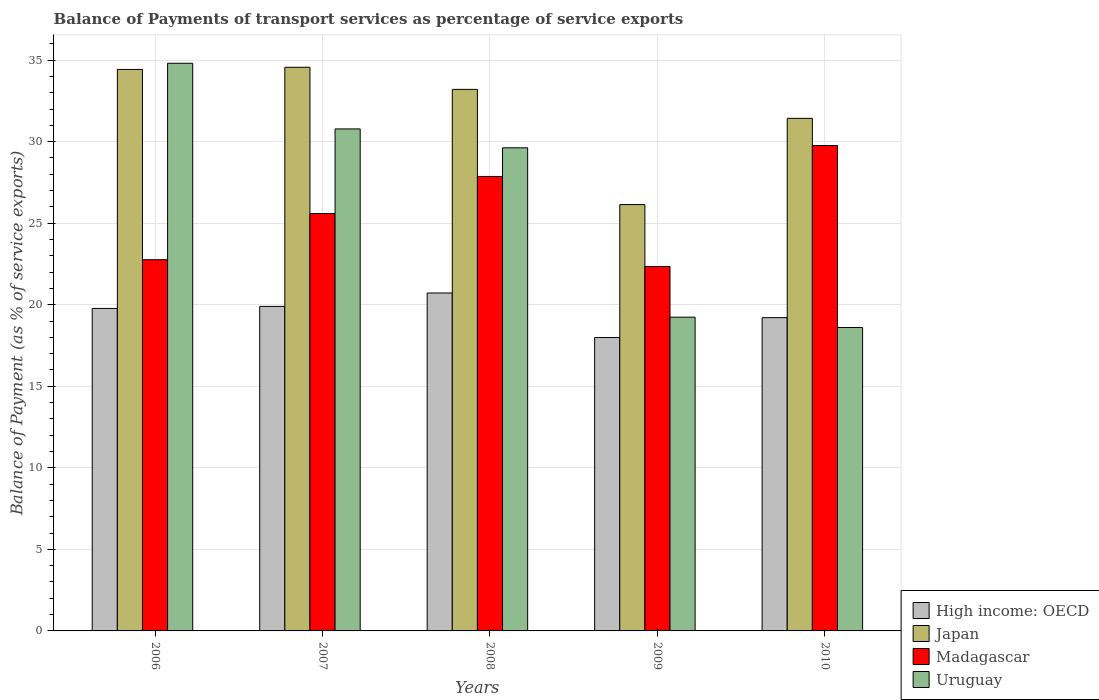How many groups of bars are there?
Provide a succinct answer. 5. Are the number of bars per tick equal to the number of legend labels?
Your response must be concise. Yes. Are the number of bars on each tick of the X-axis equal?
Provide a short and direct response. Yes. How many bars are there on the 2nd tick from the right?
Provide a short and direct response. 4. What is the balance of payments of transport services in Uruguay in 2008?
Keep it short and to the point. 29.62. Across all years, what is the maximum balance of payments of transport services in High income: OECD?
Keep it short and to the point. 20.72. Across all years, what is the minimum balance of payments of transport services in Uruguay?
Your answer should be very brief. 18.61. In which year was the balance of payments of transport services in Uruguay maximum?
Your answer should be very brief. 2006. In which year was the balance of payments of transport services in Uruguay minimum?
Your answer should be compact. 2010. What is the total balance of payments of transport services in Uruguay in the graph?
Keep it short and to the point. 133.06. What is the difference between the balance of payments of transport services in Uruguay in 2008 and that in 2010?
Your answer should be compact. 11.02. What is the difference between the balance of payments of transport services in High income: OECD in 2009 and the balance of payments of transport services in Uruguay in 2006?
Your answer should be very brief. -16.82. What is the average balance of payments of transport services in Japan per year?
Provide a short and direct response. 31.95. In the year 2008, what is the difference between the balance of payments of transport services in Japan and balance of payments of transport services in High income: OECD?
Provide a succinct answer. 12.49. In how many years, is the balance of payments of transport services in Uruguay greater than 18 %?
Provide a short and direct response. 5. What is the ratio of the balance of payments of transport services in High income: OECD in 2009 to that in 2010?
Keep it short and to the point. 0.94. Is the difference between the balance of payments of transport services in Japan in 2007 and 2009 greater than the difference between the balance of payments of transport services in High income: OECD in 2007 and 2009?
Provide a short and direct response. Yes. What is the difference between the highest and the second highest balance of payments of transport services in Japan?
Make the answer very short. 0.13. What is the difference between the highest and the lowest balance of payments of transport services in Madagascar?
Your response must be concise. 7.42. In how many years, is the balance of payments of transport services in Uruguay greater than the average balance of payments of transport services in Uruguay taken over all years?
Make the answer very short. 3. Is it the case that in every year, the sum of the balance of payments of transport services in Madagascar and balance of payments of transport services in Japan is greater than the sum of balance of payments of transport services in Uruguay and balance of payments of transport services in High income: OECD?
Your answer should be very brief. Yes. What does the 2nd bar from the left in 2010 represents?
Give a very brief answer. Japan. What does the 4th bar from the right in 2010 represents?
Make the answer very short. High income: OECD. Are all the bars in the graph horizontal?
Ensure brevity in your answer.  No. What is the difference between two consecutive major ticks on the Y-axis?
Provide a short and direct response. 5. Does the graph contain grids?
Ensure brevity in your answer.  Yes. Where does the legend appear in the graph?
Your answer should be compact. Bottom right. How many legend labels are there?
Offer a very short reply. 4. How are the legend labels stacked?
Keep it short and to the point. Vertical. What is the title of the graph?
Provide a succinct answer. Balance of Payments of transport services as percentage of service exports. What is the label or title of the Y-axis?
Keep it short and to the point. Balance of Payment (as % of service exports). What is the Balance of Payment (as % of service exports) in High income: OECD in 2006?
Offer a terse response. 19.78. What is the Balance of Payment (as % of service exports) in Japan in 2006?
Provide a short and direct response. 34.43. What is the Balance of Payment (as % of service exports) of Madagascar in 2006?
Keep it short and to the point. 22.76. What is the Balance of Payment (as % of service exports) in Uruguay in 2006?
Make the answer very short. 34.81. What is the Balance of Payment (as % of service exports) in High income: OECD in 2007?
Your response must be concise. 19.9. What is the Balance of Payment (as % of service exports) in Japan in 2007?
Make the answer very short. 34.56. What is the Balance of Payment (as % of service exports) in Madagascar in 2007?
Keep it short and to the point. 25.59. What is the Balance of Payment (as % of service exports) of Uruguay in 2007?
Offer a terse response. 30.78. What is the Balance of Payment (as % of service exports) in High income: OECD in 2008?
Give a very brief answer. 20.72. What is the Balance of Payment (as % of service exports) of Japan in 2008?
Give a very brief answer. 33.21. What is the Balance of Payment (as % of service exports) of Madagascar in 2008?
Provide a succinct answer. 27.87. What is the Balance of Payment (as % of service exports) in Uruguay in 2008?
Provide a short and direct response. 29.62. What is the Balance of Payment (as % of service exports) in High income: OECD in 2009?
Your answer should be compact. 17.99. What is the Balance of Payment (as % of service exports) of Japan in 2009?
Offer a very short reply. 26.14. What is the Balance of Payment (as % of service exports) of Madagascar in 2009?
Your answer should be compact. 22.35. What is the Balance of Payment (as % of service exports) in Uruguay in 2009?
Your answer should be compact. 19.24. What is the Balance of Payment (as % of service exports) in High income: OECD in 2010?
Provide a succinct answer. 19.21. What is the Balance of Payment (as % of service exports) in Japan in 2010?
Your answer should be compact. 31.43. What is the Balance of Payment (as % of service exports) in Madagascar in 2010?
Give a very brief answer. 29.76. What is the Balance of Payment (as % of service exports) in Uruguay in 2010?
Your answer should be compact. 18.61. Across all years, what is the maximum Balance of Payment (as % of service exports) of High income: OECD?
Ensure brevity in your answer.  20.72. Across all years, what is the maximum Balance of Payment (as % of service exports) of Japan?
Provide a succinct answer. 34.56. Across all years, what is the maximum Balance of Payment (as % of service exports) in Madagascar?
Keep it short and to the point. 29.76. Across all years, what is the maximum Balance of Payment (as % of service exports) in Uruguay?
Your answer should be compact. 34.81. Across all years, what is the minimum Balance of Payment (as % of service exports) of High income: OECD?
Ensure brevity in your answer.  17.99. Across all years, what is the minimum Balance of Payment (as % of service exports) of Japan?
Offer a very short reply. 26.14. Across all years, what is the minimum Balance of Payment (as % of service exports) in Madagascar?
Offer a terse response. 22.35. Across all years, what is the minimum Balance of Payment (as % of service exports) of Uruguay?
Offer a very short reply. 18.61. What is the total Balance of Payment (as % of service exports) in High income: OECD in the graph?
Your answer should be very brief. 97.6. What is the total Balance of Payment (as % of service exports) in Japan in the graph?
Offer a very short reply. 159.77. What is the total Balance of Payment (as % of service exports) in Madagascar in the graph?
Your answer should be compact. 128.33. What is the total Balance of Payment (as % of service exports) in Uruguay in the graph?
Your answer should be compact. 133.06. What is the difference between the Balance of Payment (as % of service exports) in High income: OECD in 2006 and that in 2007?
Your response must be concise. -0.12. What is the difference between the Balance of Payment (as % of service exports) in Japan in 2006 and that in 2007?
Offer a terse response. -0.13. What is the difference between the Balance of Payment (as % of service exports) of Madagascar in 2006 and that in 2007?
Your response must be concise. -2.83. What is the difference between the Balance of Payment (as % of service exports) of Uruguay in 2006 and that in 2007?
Offer a terse response. 4.03. What is the difference between the Balance of Payment (as % of service exports) in High income: OECD in 2006 and that in 2008?
Make the answer very short. -0.95. What is the difference between the Balance of Payment (as % of service exports) in Japan in 2006 and that in 2008?
Provide a short and direct response. 1.22. What is the difference between the Balance of Payment (as % of service exports) of Madagascar in 2006 and that in 2008?
Your answer should be very brief. -5.11. What is the difference between the Balance of Payment (as % of service exports) in Uruguay in 2006 and that in 2008?
Provide a short and direct response. 5.18. What is the difference between the Balance of Payment (as % of service exports) in High income: OECD in 2006 and that in 2009?
Offer a very short reply. 1.78. What is the difference between the Balance of Payment (as % of service exports) in Japan in 2006 and that in 2009?
Give a very brief answer. 8.29. What is the difference between the Balance of Payment (as % of service exports) in Madagascar in 2006 and that in 2009?
Provide a short and direct response. 0.42. What is the difference between the Balance of Payment (as % of service exports) of Uruguay in 2006 and that in 2009?
Provide a short and direct response. 15.57. What is the difference between the Balance of Payment (as % of service exports) in High income: OECD in 2006 and that in 2010?
Provide a succinct answer. 0.57. What is the difference between the Balance of Payment (as % of service exports) in Japan in 2006 and that in 2010?
Your response must be concise. 3. What is the difference between the Balance of Payment (as % of service exports) in Madagascar in 2006 and that in 2010?
Your answer should be very brief. -7. What is the difference between the Balance of Payment (as % of service exports) in Uruguay in 2006 and that in 2010?
Provide a short and direct response. 16.2. What is the difference between the Balance of Payment (as % of service exports) of High income: OECD in 2007 and that in 2008?
Your answer should be compact. -0.82. What is the difference between the Balance of Payment (as % of service exports) of Japan in 2007 and that in 2008?
Offer a very short reply. 1.36. What is the difference between the Balance of Payment (as % of service exports) of Madagascar in 2007 and that in 2008?
Keep it short and to the point. -2.27. What is the difference between the Balance of Payment (as % of service exports) of Uruguay in 2007 and that in 2008?
Ensure brevity in your answer.  1.16. What is the difference between the Balance of Payment (as % of service exports) of High income: OECD in 2007 and that in 2009?
Provide a succinct answer. 1.91. What is the difference between the Balance of Payment (as % of service exports) of Japan in 2007 and that in 2009?
Your answer should be very brief. 8.42. What is the difference between the Balance of Payment (as % of service exports) of Madagascar in 2007 and that in 2009?
Keep it short and to the point. 3.25. What is the difference between the Balance of Payment (as % of service exports) in Uruguay in 2007 and that in 2009?
Ensure brevity in your answer.  11.54. What is the difference between the Balance of Payment (as % of service exports) of High income: OECD in 2007 and that in 2010?
Keep it short and to the point. 0.69. What is the difference between the Balance of Payment (as % of service exports) of Japan in 2007 and that in 2010?
Provide a succinct answer. 3.13. What is the difference between the Balance of Payment (as % of service exports) in Madagascar in 2007 and that in 2010?
Your answer should be very brief. -4.17. What is the difference between the Balance of Payment (as % of service exports) in Uruguay in 2007 and that in 2010?
Provide a short and direct response. 12.18. What is the difference between the Balance of Payment (as % of service exports) in High income: OECD in 2008 and that in 2009?
Your answer should be compact. 2.73. What is the difference between the Balance of Payment (as % of service exports) in Japan in 2008 and that in 2009?
Your answer should be very brief. 7.06. What is the difference between the Balance of Payment (as % of service exports) in Madagascar in 2008 and that in 2009?
Provide a short and direct response. 5.52. What is the difference between the Balance of Payment (as % of service exports) of Uruguay in 2008 and that in 2009?
Ensure brevity in your answer.  10.39. What is the difference between the Balance of Payment (as % of service exports) of High income: OECD in 2008 and that in 2010?
Make the answer very short. 1.51. What is the difference between the Balance of Payment (as % of service exports) in Japan in 2008 and that in 2010?
Give a very brief answer. 1.78. What is the difference between the Balance of Payment (as % of service exports) of Madagascar in 2008 and that in 2010?
Your response must be concise. -1.9. What is the difference between the Balance of Payment (as % of service exports) in Uruguay in 2008 and that in 2010?
Offer a terse response. 11.02. What is the difference between the Balance of Payment (as % of service exports) of High income: OECD in 2009 and that in 2010?
Offer a very short reply. -1.22. What is the difference between the Balance of Payment (as % of service exports) of Japan in 2009 and that in 2010?
Provide a succinct answer. -5.29. What is the difference between the Balance of Payment (as % of service exports) in Madagascar in 2009 and that in 2010?
Ensure brevity in your answer.  -7.42. What is the difference between the Balance of Payment (as % of service exports) in Uruguay in 2009 and that in 2010?
Give a very brief answer. 0.63. What is the difference between the Balance of Payment (as % of service exports) of High income: OECD in 2006 and the Balance of Payment (as % of service exports) of Japan in 2007?
Make the answer very short. -14.79. What is the difference between the Balance of Payment (as % of service exports) of High income: OECD in 2006 and the Balance of Payment (as % of service exports) of Madagascar in 2007?
Your answer should be very brief. -5.82. What is the difference between the Balance of Payment (as % of service exports) in High income: OECD in 2006 and the Balance of Payment (as % of service exports) in Uruguay in 2007?
Make the answer very short. -11.01. What is the difference between the Balance of Payment (as % of service exports) in Japan in 2006 and the Balance of Payment (as % of service exports) in Madagascar in 2007?
Give a very brief answer. 8.84. What is the difference between the Balance of Payment (as % of service exports) in Japan in 2006 and the Balance of Payment (as % of service exports) in Uruguay in 2007?
Ensure brevity in your answer.  3.65. What is the difference between the Balance of Payment (as % of service exports) in Madagascar in 2006 and the Balance of Payment (as % of service exports) in Uruguay in 2007?
Provide a short and direct response. -8.02. What is the difference between the Balance of Payment (as % of service exports) in High income: OECD in 2006 and the Balance of Payment (as % of service exports) in Japan in 2008?
Ensure brevity in your answer.  -13.43. What is the difference between the Balance of Payment (as % of service exports) of High income: OECD in 2006 and the Balance of Payment (as % of service exports) of Madagascar in 2008?
Your response must be concise. -8.09. What is the difference between the Balance of Payment (as % of service exports) in High income: OECD in 2006 and the Balance of Payment (as % of service exports) in Uruguay in 2008?
Provide a short and direct response. -9.85. What is the difference between the Balance of Payment (as % of service exports) in Japan in 2006 and the Balance of Payment (as % of service exports) in Madagascar in 2008?
Provide a short and direct response. 6.56. What is the difference between the Balance of Payment (as % of service exports) of Japan in 2006 and the Balance of Payment (as % of service exports) of Uruguay in 2008?
Keep it short and to the point. 4.81. What is the difference between the Balance of Payment (as % of service exports) of Madagascar in 2006 and the Balance of Payment (as % of service exports) of Uruguay in 2008?
Make the answer very short. -6.86. What is the difference between the Balance of Payment (as % of service exports) in High income: OECD in 2006 and the Balance of Payment (as % of service exports) in Japan in 2009?
Your response must be concise. -6.37. What is the difference between the Balance of Payment (as % of service exports) in High income: OECD in 2006 and the Balance of Payment (as % of service exports) in Madagascar in 2009?
Provide a short and direct response. -2.57. What is the difference between the Balance of Payment (as % of service exports) in High income: OECD in 2006 and the Balance of Payment (as % of service exports) in Uruguay in 2009?
Ensure brevity in your answer.  0.54. What is the difference between the Balance of Payment (as % of service exports) of Japan in 2006 and the Balance of Payment (as % of service exports) of Madagascar in 2009?
Offer a very short reply. 12.08. What is the difference between the Balance of Payment (as % of service exports) in Japan in 2006 and the Balance of Payment (as % of service exports) in Uruguay in 2009?
Keep it short and to the point. 15.19. What is the difference between the Balance of Payment (as % of service exports) in Madagascar in 2006 and the Balance of Payment (as % of service exports) in Uruguay in 2009?
Make the answer very short. 3.52. What is the difference between the Balance of Payment (as % of service exports) of High income: OECD in 2006 and the Balance of Payment (as % of service exports) of Japan in 2010?
Ensure brevity in your answer.  -11.65. What is the difference between the Balance of Payment (as % of service exports) of High income: OECD in 2006 and the Balance of Payment (as % of service exports) of Madagascar in 2010?
Offer a terse response. -9.99. What is the difference between the Balance of Payment (as % of service exports) in High income: OECD in 2006 and the Balance of Payment (as % of service exports) in Uruguay in 2010?
Your answer should be compact. 1.17. What is the difference between the Balance of Payment (as % of service exports) in Japan in 2006 and the Balance of Payment (as % of service exports) in Madagascar in 2010?
Give a very brief answer. 4.67. What is the difference between the Balance of Payment (as % of service exports) of Japan in 2006 and the Balance of Payment (as % of service exports) of Uruguay in 2010?
Your answer should be very brief. 15.82. What is the difference between the Balance of Payment (as % of service exports) in Madagascar in 2006 and the Balance of Payment (as % of service exports) in Uruguay in 2010?
Offer a very short reply. 4.16. What is the difference between the Balance of Payment (as % of service exports) in High income: OECD in 2007 and the Balance of Payment (as % of service exports) in Japan in 2008?
Your answer should be very brief. -13.31. What is the difference between the Balance of Payment (as % of service exports) of High income: OECD in 2007 and the Balance of Payment (as % of service exports) of Madagascar in 2008?
Your response must be concise. -7.97. What is the difference between the Balance of Payment (as % of service exports) in High income: OECD in 2007 and the Balance of Payment (as % of service exports) in Uruguay in 2008?
Offer a very short reply. -9.72. What is the difference between the Balance of Payment (as % of service exports) in Japan in 2007 and the Balance of Payment (as % of service exports) in Madagascar in 2008?
Provide a succinct answer. 6.69. What is the difference between the Balance of Payment (as % of service exports) in Japan in 2007 and the Balance of Payment (as % of service exports) in Uruguay in 2008?
Offer a terse response. 4.94. What is the difference between the Balance of Payment (as % of service exports) in Madagascar in 2007 and the Balance of Payment (as % of service exports) in Uruguay in 2008?
Offer a terse response. -4.03. What is the difference between the Balance of Payment (as % of service exports) of High income: OECD in 2007 and the Balance of Payment (as % of service exports) of Japan in 2009?
Offer a very short reply. -6.24. What is the difference between the Balance of Payment (as % of service exports) in High income: OECD in 2007 and the Balance of Payment (as % of service exports) in Madagascar in 2009?
Your answer should be very brief. -2.45. What is the difference between the Balance of Payment (as % of service exports) of High income: OECD in 2007 and the Balance of Payment (as % of service exports) of Uruguay in 2009?
Provide a succinct answer. 0.66. What is the difference between the Balance of Payment (as % of service exports) of Japan in 2007 and the Balance of Payment (as % of service exports) of Madagascar in 2009?
Offer a terse response. 12.22. What is the difference between the Balance of Payment (as % of service exports) of Japan in 2007 and the Balance of Payment (as % of service exports) of Uruguay in 2009?
Your answer should be compact. 15.32. What is the difference between the Balance of Payment (as % of service exports) of Madagascar in 2007 and the Balance of Payment (as % of service exports) of Uruguay in 2009?
Your answer should be very brief. 6.35. What is the difference between the Balance of Payment (as % of service exports) in High income: OECD in 2007 and the Balance of Payment (as % of service exports) in Japan in 2010?
Provide a short and direct response. -11.53. What is the difference between the Balance of Payment (as % of service exports) in High income: OECD in 2007 and the Balance of Payment (as % of service exports) in Madagascar in 2010?
Your answer should be very brief. -9.86. What is the difference between the Balance of Payment (as % of service exports) of High income: OECD in 2007 and the Balance of Payment (as % of service exports) of Uruguay in 2010?
Your answer should be very brief. 1.29. What is the difference between the Balance of Payment (as % of service exports) in Japan in 2007 and the Balance of Payment (as % of service exports) in Madagascar in 2010?
Ensure brevity in your answer.  4.8. What is the difference between the Balance of Payment (as % of service exports) of Japan in 2007 and the Balance of Payment (as % of service exports) of Uruguay in 2010?
Offer a terse response. 15.96. What is the difference between the Balance of Payment (as % of service exports) of Madagascar in 2007 and the Balance of Payment (as % of service exports) of Uruguay in 2010?
Make the answer very short. 6.99. What is the difference between the Balance of Payment (as % of service exports) in High income: OECD in 2008 and the Balance of Payment (as % of service exports) in Japan in 2009?
Offer a very short reply. -5.42. What is the difference between the Balance of Payment (as % of service exports) in High income: OECD in 2008 and the Balance of Payment (as % of service exports) in Madagascar in 2009?
Offer a terse response. -1.62. What is the difference between the Balance of Payment (as % of service exports) of High income: OECD in 2008 and the Balance of Payment (as % of service exports) of Uruguay in 2009?
Keep it short and to the point. 1.48. What is the difference between the Balance of Payment (as % of service exports) in Japan in 2008 and the Balance of Payment (as % of service exports) in Madagascar in 2009?
Keep it short and to the point. 10.86. What is the difference between the Balance of Payment (as % of service exports) in Japan in 2008 and the Balance of Payment (as % of service exports) in Uruguay in 2009?
Ensure brevity in your answer.  13.97. What is the difference between the Balance of Payment (as % of service exports) of Madagascar in 2008 and the Balance of Payment (as % of service exports) of Uruguay in 2009?
Offer a terse response. 8.63. What is the difference between the Balance of Payment (as % of service exports) in High income: OECD in 2008 and the Balance of Payment (as % of service exports) in Japan in 2010?
Provide a short and direct response. -10.71. What is the difference between the Balance of Payment (as % of service exports) of High income: OECD in 2008 and the Balance of Payment (as % of service exports) of Madagascar in 2010?
Give a very brief answer. -9.04. What is the difference between the Balance of Payment (as % of service exports) of High income: OECD in 2008 and the Balance of Payment (as % of service exports) of Uruguay in 2010?
Your response must be concise. 2.12. What is the difference between the Balance of Payment (as % of service exports) in Japan in 2008 and the Balance of Payment (as % of service exports) in Madagascar in 2010?
Your answer should be very brief. 3.44. What is the difference between the Balance of Payment (as % of service exports) of Japan in 2008 and the Balance of Payment (as % of service exports) of Uruguay in 2010?
Provide a short and direct response. 14.6. What is the difference between the Balance of Payment (as % of service exports) in Madagascar in 2008 and the Balance of Payment (as % of service exports) in Uruguay in 2010?
Give a very brief answer. 9.26. What is the difference between the Balance of Payment (as % of service exports) of High income: OECD in 2009 and the Balance of Payment (as % of service exports) of Japan in 2010?
Your answer should be very brief. -13.44. What is the difference between the Balance of Payment (as % of service exports) of High income: OECD in 2009 and the Balance of Payment (as % of service exports) of Madagascar in 2010?
Offer a very short reply. -11.77. What is the difference between the Balance of Payment (as % of service exports) of High income: OECD in 2009 and the Balance of Payment (as % of service exports) of Uruguay in 2010?
Offer a terse response. -0.61. What is the difference between the Balance of Payment (as % of service exports) of Japan in 2009 and the Balance of Payment (as % of service exports) of Madagascar in 2010?
Give a very brief answer. -3.62. What is the difference between the Balance of Payment (as % of service exports) of Japan in 2009 and the Balance of Payment (as % of service exports) of Uruguay in 2010?
Provide a short and direct response. 7.54. What is the difference between the Balance of Payment (as % of service exports) of Madagascar in 2009 and the Balance of Payment (as % of service exports) of Uruguay in 2010?
Offer a terse response. 3.74. What is the average Balance of Payment (as % of service exports) in High income: OECD per year?
Keep it short and to the point. 19.52. What is the average Balance of Payment (as % of service exports) in Japan per year?
Keep it short and to the point. 31.95. What is the average Balance of Payment (as % of service exports) in Madagascar per year?
Offer a very short reply. 25.67. What is the average Balance of Payment (as % of service exports) in Uruguay per year?
Keep it short and to the point. 26.61. In the year 2006, what is the difference between the Balance of Payment (as % of service exports) of High income: OECD and Balance of Payment (as % of service exports) of Japan?
Offer a very short reply. -14.65. In the year 2006, what is the difference between the Balance of Payment (as % of service exports) in High income: OECD and Balance of Payment (as % of service exports) in Madagascar?
Provide a short and direct response. -2.99. In the year 2006, what is the difference between the Balance of Payment (as % of service exports) of High income: OECD and Balance of Payment (as % of service exports) of Uruguay?
Keep it short and to the point. -15.03. In the year 2006, what is the difference between the Balance of Payment (as % of service exports) in Japan and Balance of Payment (as % of service exports) in Madagascar?
Make the answer very short. 11.67. In the year 2006, what is the difference between the Balance of Payment (as % of service exports) in Japan and Balance of Payment (as % of service exports) in Uruguay?
Make the answer very short. -0.38. In the year 2006, what is the difference between the Balance of Payment (as % of service exports) of Madagascar and Balance of Payment (as % of service exports) of Uruguay?
Make the answer very short. -12.05. In the year 2007, what is the difference between the Balance of Payment (as % of service exports) in High income: OECD and Balance of Payment (as % of service exports) in Japan?
Provide a short and direct response. -14.66. In the year 2007, what is the difference between the Balance of Payment (as % of service exports) of High income: OECD and Balance of Payment (as % of service exports) of Madagascar?
Your answer should be very brief. -5.69. In the year 2007, what is the difference between the Balance of Payment (as % of service exports) of High income: OECD and Balance of Payment (as % of service exports) of Uruguay?
Ensure brevity in your answer.  -10.88. In the year 2007, what is the difference between the Balance of Payment (as % of service exports) in Japan and Balance of Payment (as % of service exports) in Madagascar?
Give a very brief answer. 8.97. In the year 2007, what is the difference between the Balance of Payment (as % of service exports) of Japan and Balance of Payment (as % of service exports) of Uruguay?
Offer a very short reply. 3.78. In the year 2007, what is the difference between the Balance of Payment (as % of service exports) of Madagascar and Balance of Payment (as % of service exports) of Uruguay?
Keep it short and to the point. -5.19. In the year 2008, what is the difference between the Balance of Payment (as % of service exports) of High income: OECD and Balance of Payment (as % of service exports) of Japan?
Offer a terse response. -12.49. In the year 2008, what is the difference between the Balance of Payment (as % of service exports) of High income: OECD and Balance of Payment (as % of service exports) of Madagascar?
Ensure brevity in your answer.  -7.15. In the year 2008, what is the difference between the Balance of Payment (as % of service exports) in High income: OECD and Balance of Payment (as % of service exports) in Uruguay?
Make the answer very short. -8.9. In the year 2008, what is the difference between the Balance of Payment (as % of service exports) in Japan and Balance of Payment (as % of service exports) in Madagascar?
Give a very brief answer. 5.34. In the year 2008, what is the difference between the Balance of Payment (as % of service exports) in Japan and Balance of Payment (as % of service exports) in Uruguay?
Provide a short and direct response. 3.58. In the year 2008, what is the difference between the Balance of Payment (as % of service exports) of Madagascar and Balance of Payment (as % of service exports) of Uruguay?
Your response must be concise. -1.76. In the year 2009, what is the difference between the Balance of Payment (as % of service exports) of High income: OECD and Balance of Payment (as % of service exports) of Japan?
Give a very brief answer. -8.15. In the year 2009, what is the difference between the Balance of Payment (as % of service exports) in High income: OECD and Balance of Payment (as % of service exports) in Madagascar?
Provide a succinct answer. -4.35. In the year 2009, what is the difference between the Balance of Payment (as % of service exports) of High income: OECD and Balance of Payment (as % of service exports) of Uruguay?
Provide a short and direct response. -1.25. In the year 2009, what is the difference between the Balance of Payment (as % of service exports) in Japan and Balance of Payment (as % of service exports) in Madagascar?
Offer a very short reply. 3.8. In the year 2009, what is the difference between the Balance of Payment (as % of service exports) of Japan and Balance of Payment (as % of service exports) of Uruguay?
Provide a succinct answer. 6.91. In the year 2009, what is the difference between the Balance of Payment (as % of service exports) in Madagascar and Balance of Payment (as % of service exports) in Uruguay?
Offer a terse response. 3.11. In the year 2010, what is the difference between the Balance of Payment (as % of service exports) in High income: OECD and Balance of Payment (as % of service exports) in Japan?
Keep it short and to the point. -12.22. In the year 2010, what is the difference between the Balance of Payment (as % of service exports) in High income: OECD and Balance of Payment (as % of service exports) in Madagascar?
Give a very brief answer. -10.55. In the year 2010, what is the difference between the Balance of Payment (as % of service exports) in High income: OECD and Balance of Payment (as % of service exports) in Uruguay?
Give a very brief answer. 0.6. In the year 2010, what is the difference between the Balance of Payment (as % of service exports) in Japan and Balance of Payment (as % of service exports) in Madagascar?
Keep it short and to the point. 1.67. In the year 2010, what is the difference between the Balance of Payment (as % of service exports) in Japan and Balance of Payment (as % of service exports) in Uruguay?
Ensure brevity in your answer.  12.82. In the year 2010, what is the difference between the Balance of Payment (as % of service exports) in Madagascar and Balance of Payment (as % of service exports) in Uruguay?
Ensure brevity in your answer.  11.16. What is the ratio of the Balance of Payment (as % of service exports) of High income: OECD in 2006 to that in 2007?
Your response must be concise. 0.99. What is the ratio of the Balance of Payment (as % of service exports) in Japan in 2006 to that in 2007?
Make the answer very short. 1. What is the ratio of the Balance of Payment (as % of service exports) of Madagascar in 2006 to that in 2007?
Offer a very short reply. 0.89. What is the ratio of the Balance of Payment (as % of service exports) in Uruguay in 2006 to that in 2007?
Your answer should be very brief. 1.13. What is the ratio of the Balance of Payment (as % of service exports) of High income: OECD in 2006 to that in 2008?
Keep it short and to the point. 0.95. What is the ratio of the Balance of Payment (as % of service exports) in Japan in 2006 to that in 2008?
Give a very brief answer. 1.04. What is the ratio of the Balance of Payment (as % of service exports) in Madagascar in 2006 to that in 2008?
Your answer should be compact. 0.82. What is the ratio of the Balance of Payment (as % of service exports) of Uruguay in 2006 to that in 2008?
Offer a very short reply. 1.18. What is the ratio of the Balance of Payment (as % of service exports) of High income: OECD in 2006 to that in 2009?
Make the answer very short. 1.1. What is the ratio of the Balance of Payment (as % of service exports) in Japan in 2006 to that in 2009?
Offer a terse response. 1.32. What is the ratio of the Balance of Payment (as % of service exports) in Madagascar in 2006 to that in 2009?
Your answer should be very brief. 1.02. What is the ratio of the Balance of Payment (as % of service exports) in Uruguay in 2006 to that in 2009?
Provide a short and direct response. 1.81. What is the ratio of the Balance of Payment (as % of service exports) in High income: OECD in 2006 to that in 2010?
Offer a terse response. 1.03. What is the ratio of the Balance of Payment (as % of service exports) in Japan in 2006 to that in 2010?
Your response must be concise. 1.1. What is the ratio of the Balance of Payment (as % of service exports) in Madagascar in 2006 to that in 2010?
Provide a short and direct response. 0.76. What is the ratio of the Balance of Payment (as % of service exports) of Uruguay in 2006 to that in 2010?
Ensure brevity in your answer.  1.87. What is the ratio of the Balance of Payment (as % of service exports) in High income: OECD in 2007 to that in 2008?
Keep it short and to the point. 0.96. What is the ratio of the Balance of Payment (as % of service exports) in Japan in 2007 to that in 2008?
Keep it short and to the point. 1.04. What is the ratio of the Balance of Payment (as % of service exports) of Madagascar in 2007 to that in 2008?
Ensure brevity in your answer.  0.92. What is the ratio of the Balance of Payment (as % of service exports) of Uruguay in 2007 to that in 2008?
Make the answer very short. 1.04. What is the ratio of the Balance of Payment (as % of service exports) in High income: OECD in 2007 to that in 2009?
Provide a succinct answer. 1.11. What is the ratio of the Balance of Payment (as % of service exports) in Japan in 2007 to that in 2009?
Offer a terse response. 1.32. What is the ratio of the Balance of Payment (as % of service exports) in Madagascar in 2007 to that in 2009?
Provide a short and direct response. 1.15. What is the ratio of the Balance of Payment (as % of service exports) of Uruguay in 2007 to that in 2009?
Offer a terse response. 1.6. What is the ratio of the Balance of Payment (as % of service exports) in High income: OECD in 2007 to that in 2010?
Provide a short and direct response. 1.04. What is the ratio of the Balance of Payment (as % of service exports) of Japan in 2007 to that in 2010?
Provide a succinct answer. 1.1. What is the ratio of the Balance of Payment (as % of service exports) of Madagascar in 2007 to that in 2010?
Make the answer very short. 0.86. What is the ratio of the Balance of Payment (as % of service exports) in Uruguay in 2007 to that in 2010?
Provide a succinct answer. 1.65. What is the ratio of the Balance of Payment (as % of service exports) in High income: OECD in 2008 to that in 2009?
Your response must be concise. 1.15. What is the ratio of the Balance of Payment (as % of service exports) of Japan in 2008 to that in 2009?
Provide a succinct answer. 1.27. What is the ratio of the Balance of Payment (as % of service exports) in Madagascar in 2008 to that in 2009?
Provide a succinct answer. 1.25. What is the ratio of the Balance of Payment (as % of service exports) in Uruguay in 2008 to that in 2009?
Offer a very short reply. 1.54. What is the ratio of the Balance of Payment (as % of service exports) of High income: OECD in 2008 to that in 2010?
Offer a very short reply. 1.08. What is the ratio of the Balance of Payment (as % of service exports) of Japan in 2008 to that in 2010?
Offer a terse response. 1.06. What is the ratio of the Balance of Payment (as % of service exports) of Madagascar in 2008 to that in 2010?
Your response must be concise. 0.94. What is the ratio of the Balance of Payment (as % of service exports) in Uruguay in 2008 to that in 2010?
Your answer should be compact. 1.59. What is the ratio of the Balance of Payment (as % of service exports) in High income: OECD in 2009 to that in 2010?
Keep it short and to the point. 0.94. What is the ratio of the Balance of Payment (as % of service exports) of Japan in 2009 to that in 2010?
Offer a very short reply. 0.83. What is the ratio of the Balance of Payment (as % of service exports) of Madagascar in 2009 to that in 2010?
Your answer should be compact. 0.75. What is the ratio of the Balance of Payment (as % of service exports) of Uruguay in 2009 to that in 2010?
Offer a very short reply. 1.03. What is the difference between the highest and the second highest Balance of Payment (as % of service exports) in High income: OECD?
Your answer should be very brief. 0.82. What is the difference between the highest and the second highest Balance of Payment (as % of service exports) of Japan?
Your response must be concise. 0.13. What is the difference between the highest and the second highest Balance of Payment (as % of service exports) in Madagascar?
Your answer should be compact. 1.9. What is the difference between the highest and the second highest Balance of Payment (as % of service exports) of Uruguay?
Offer a terse response. 4.03. What is the difference between the highest and the lowest Balance of Payment (as % of service exports) of High income: OECD?
Your answer should be compact. 2.73. What is the difference between the highest and the lowest Balance of Payment (as % of service exports) in Japan?
Offer a terse response. 8.42. What is the difference between the highest and the lowest Balance of Payment (as % of service exports) of Madagascar?
Your answer should be very brief. 7.42. What is the difference between the highest and the lowest Balance of Payment (as % of service exports) in Uruguay?
Provide a succinct answer. 16.2. 